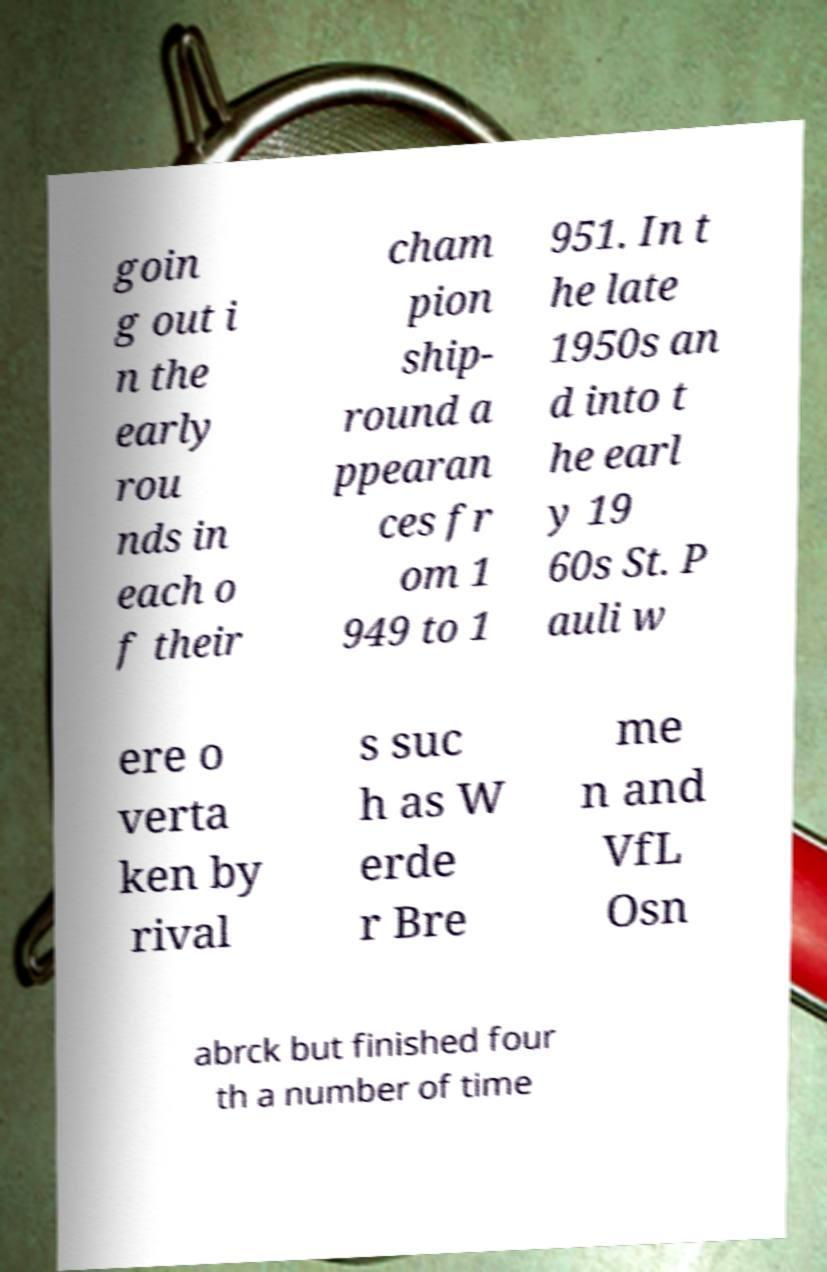Can you read and provide the text displayed in the image?This photo seems to have some interesting text. Can you extract and type it out for me? goin g out i n the early rou nds in each o f their cham pion ship- round a ppearan ces fr om 1 949 to 1 951. In t he late 1950s an d into t he earl y 19 60s St. P auli w ere o verta ken by rival s suc h as W erde r Bre me n and VfL Osn abrck but finished four th a number of time 